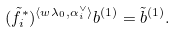Convert formula to latex. <formula><loc_0><loc_0><loc_500><loc_500>( \tilde { f } _ { i } ^ { \ast } ) ^ { \langle w \lambda _ { 0 } , \alpha _ { i } ^ { \vee } \rangle } b ^ { ( 1 ) } = \tilde { b } ^ { ( 1 ) } .</formula> 